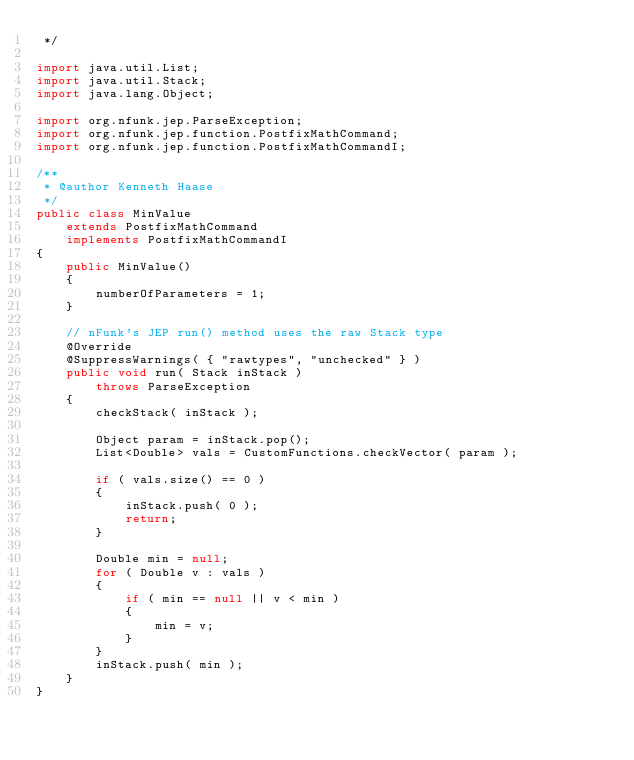<code> <loc_0><loc_0><loc_500><loc_500><_Java_> */

import java.util.List;
import java.util.Stack;
import java.lang.Object;

import org.nfunk.jep.ParseException;
import org.nfunk.jep.function.PostfixMathCommand;
import org.nfunk.jep.function.PostfixMathCommandI;

/**
 * @author Kenneth Haase
 */
public class MinValue
    extends PostfixMathCommand
    implements PostfixMathCommandI
{
    public MinValue()
    {
        numberOfParameters = 1;
    }

    // nFunk's JEP run() method uses the raw Stack type
    @Override
    @SuppressWarnings( { "rawtypes", "unchecked" } )
    public void run( Stack inStack )
        throws ParseException
    {
        checkStack( inStack );

        Object param = inStack.pop();
        List<Double> vals = CustomFunctions.checkVector( param );

        if ( vals.size() == 0 )
        {
            inStack.push( 0 );
            return;
        }

        Double min = null;
        for ( Double v : vals )
        {
            if ( min == null || v < min )
            {
                min = v;
            }
        }
        inStack.push( min );
    }
}
</code> 